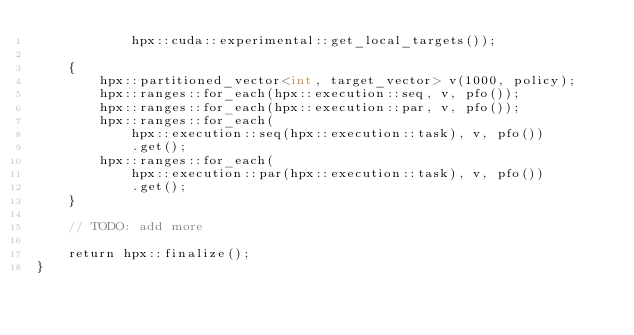<code> <loc_0><loc_0><loc_500><loc_500><_Cuda_>            hpx::cuda::experimental::get_local_targets());

    {
        hpx::partitioned_vector<int, target_vector> v(1000, policy);
        hpx::ranges::for_each(hpx::execution::seq, v, pfo());
        hpx::ranges::for_each(hpx::execution::par, v, pfo());
        hpx::ranges::for_each(
            hpx::execution::seq(hpx::execution::task), v, pfo())
            .get();
        hpx::ranges::for_each(
            hpx::execution::par(hpx::execution::task), v, pfo())
            .get();
    }

    // TODO: add more

    return hpx::finalize();
}
</code> 